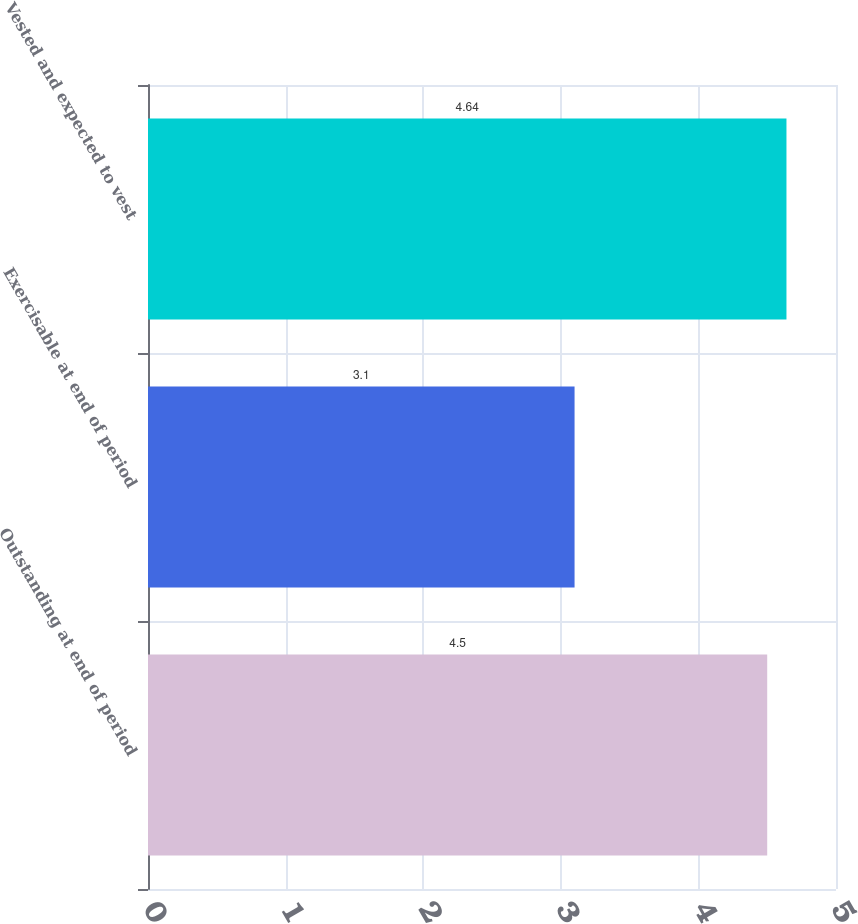<chart> <loc_0><loc_0><loc_500><loc_500><bar_chart><fcel>Outstanding at end of period<fcel>Exercisable at end of period<fcel>Vested and expected to vest<nl><fcel>4.5<fcel>3.1<fcel>4.64<nl></chart> 